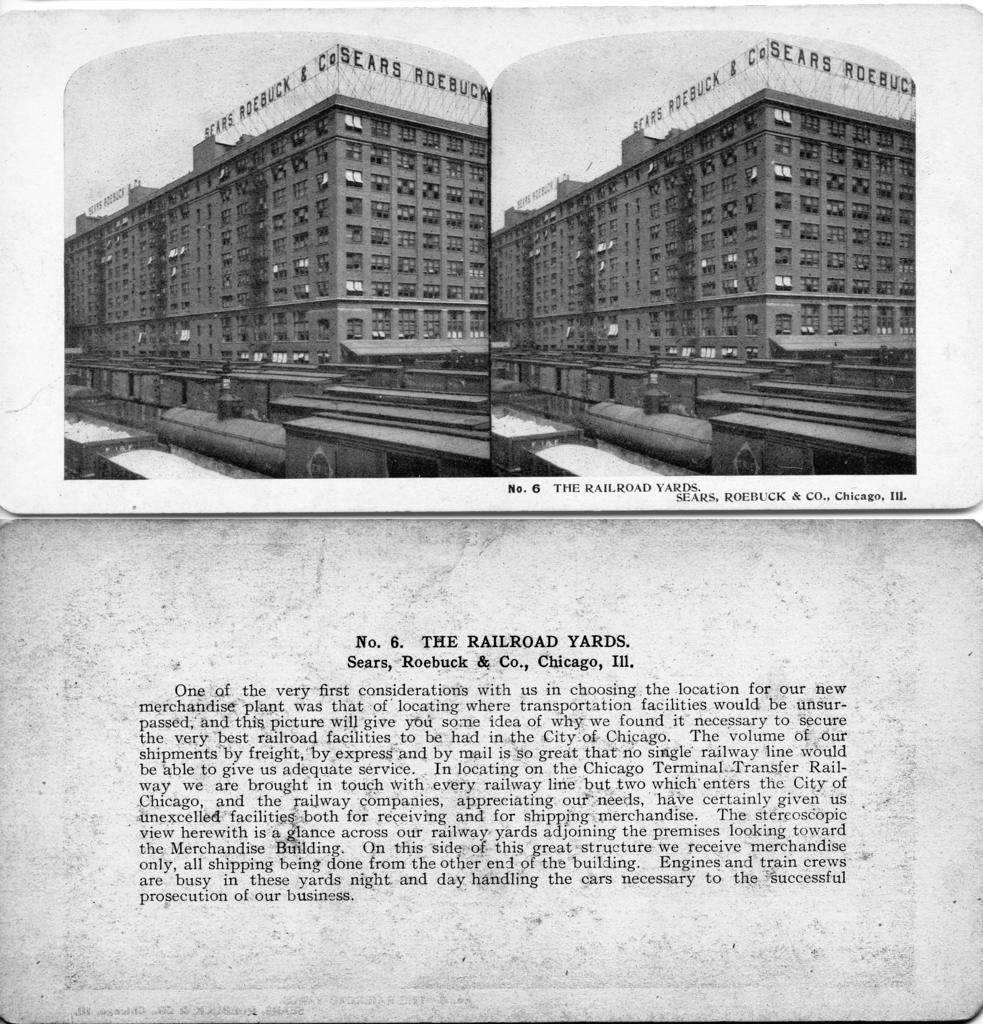Could you give a brief overview of what you see in this image? In this picture I can see two papers. In the top paper there is a collage of same images. On the image there is a building with name. At the bottom paper there is something written. 